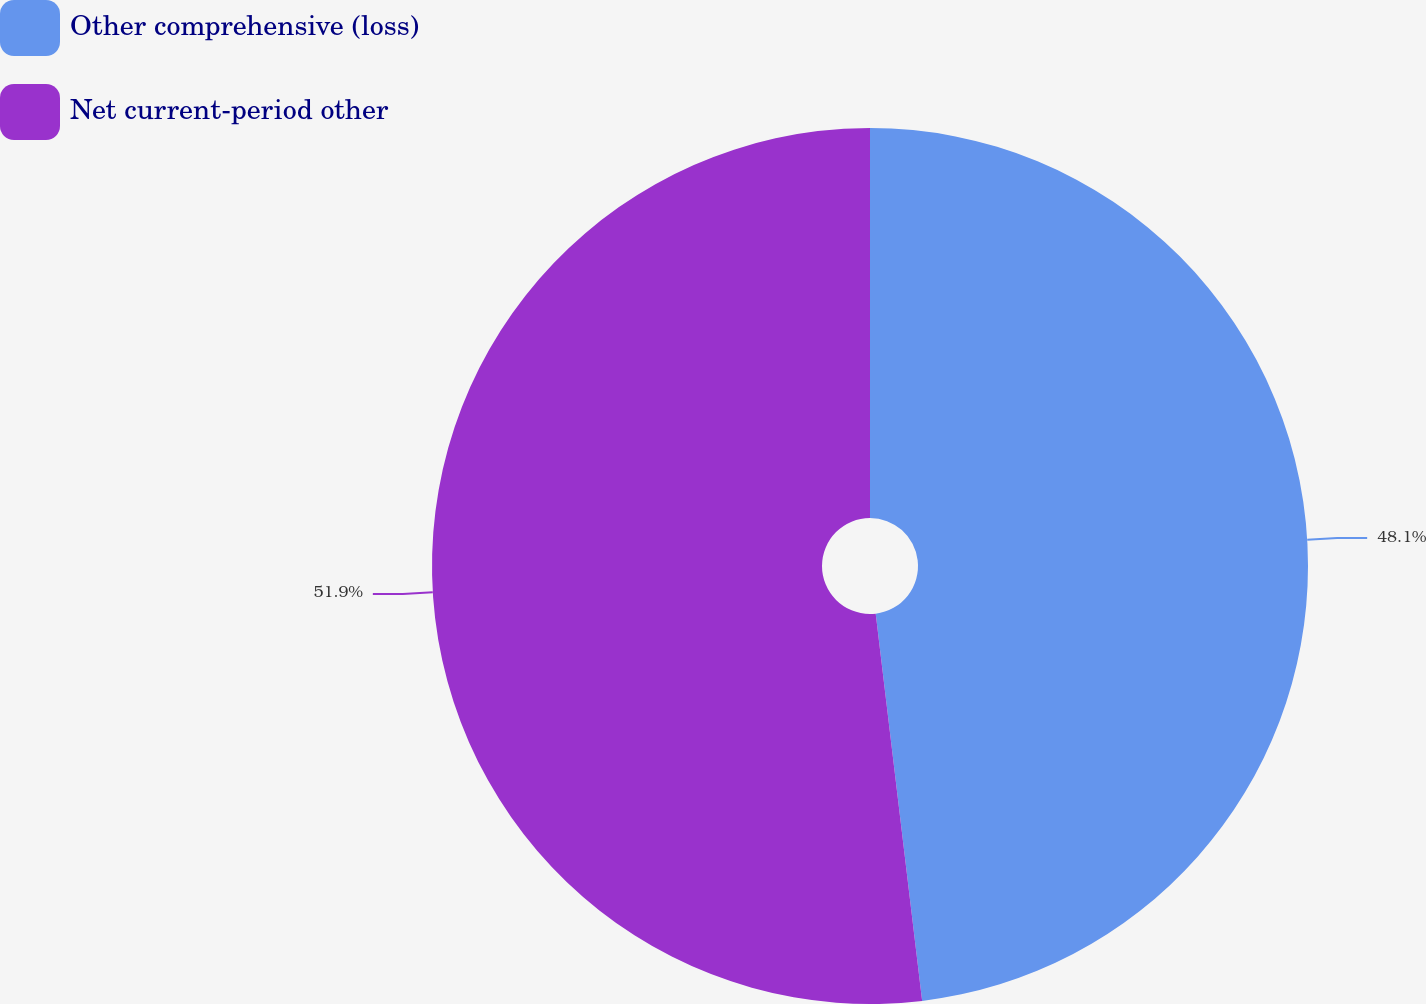<chart> <loc_0><loc_0><loc_500><loc_500><pie_chart><fcel>Other comprehensive (loss)<fcel>Net current-period other<nl><fcel>48.1%<fcel>51.9%<nl></chart> 